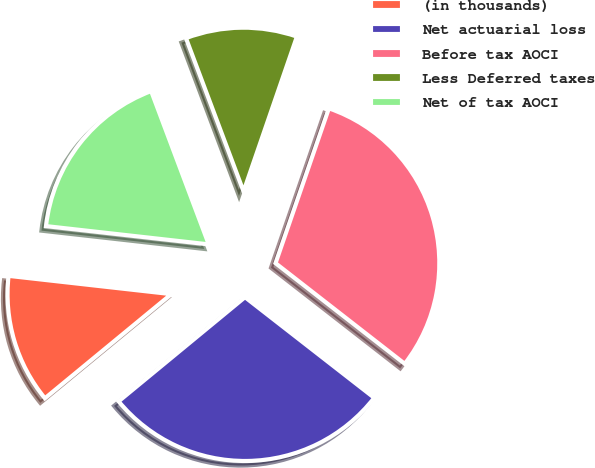<chart> <loc_0><loc_0><loc_500><loc_500><pie_chart><fcel>(in thousands)<fcel>Net actuarial loss<fcel>Before tax AOCI<fcel>Less Deferred taxes<fcel>Net of tax AOCI<nl><fcel>12.75%<fcel>28.5%<fcel>30.25%<fcel>11.0%<fcel>17.5%<nl></chart> 